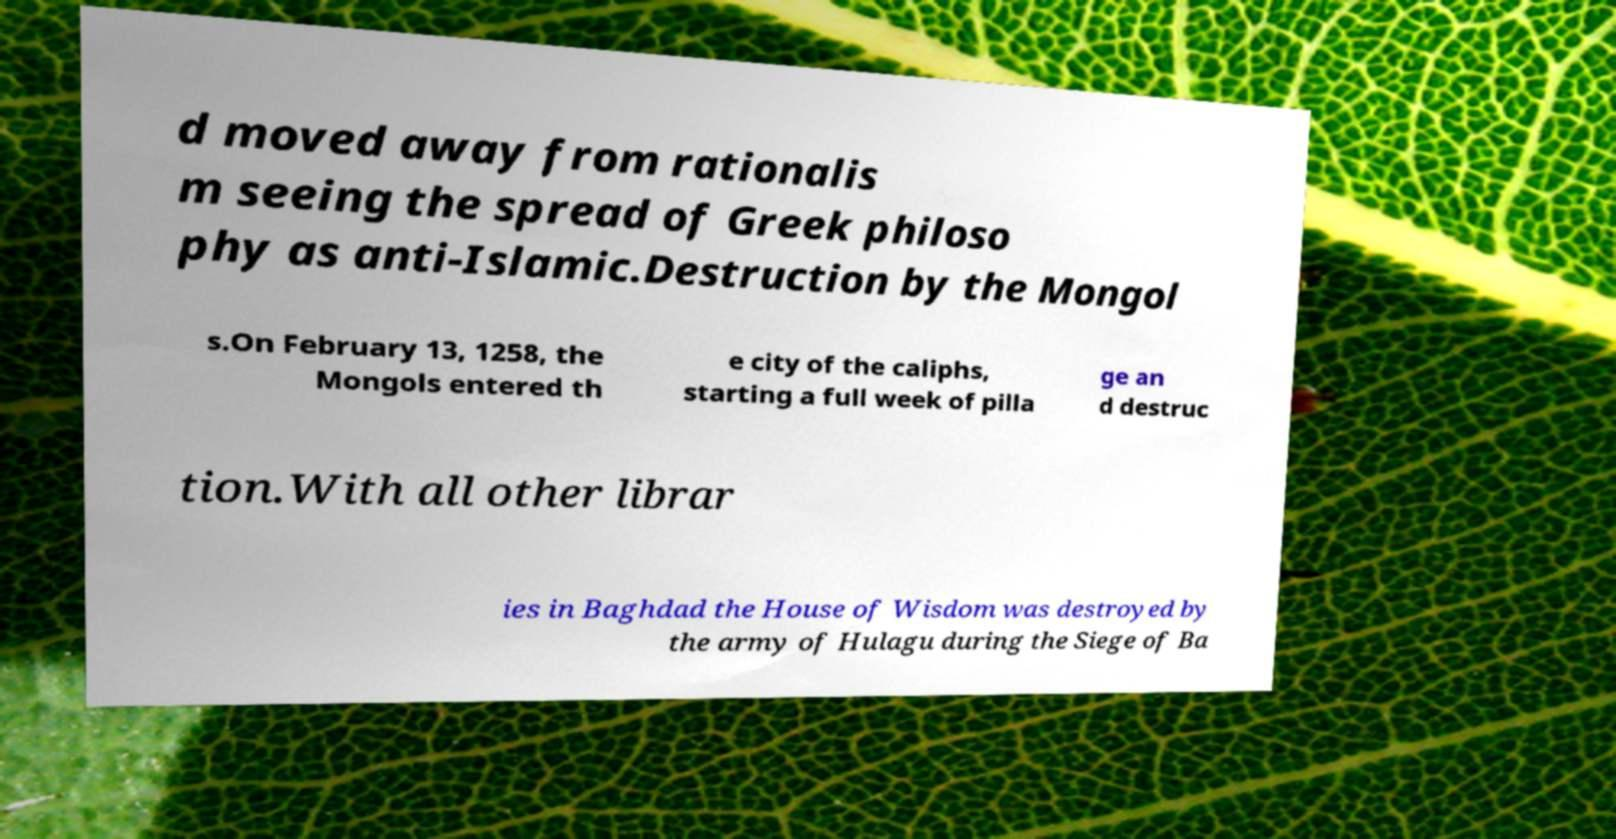Could you assist in decoding the text presented in this image and type it out clearly? d moved away from rationalis m seeing the spread of Greek philoso phy as anti-Islamic.Destruction by the Mongol s.On February 13, 1258, the Mongols entered th e city of the caliphs, starting a full week of pilla ge an d destruc tion.With all other librar ies in Baghdad the House of Wisdom was destroyed by the army of Hulagu during the Siege of Ba 